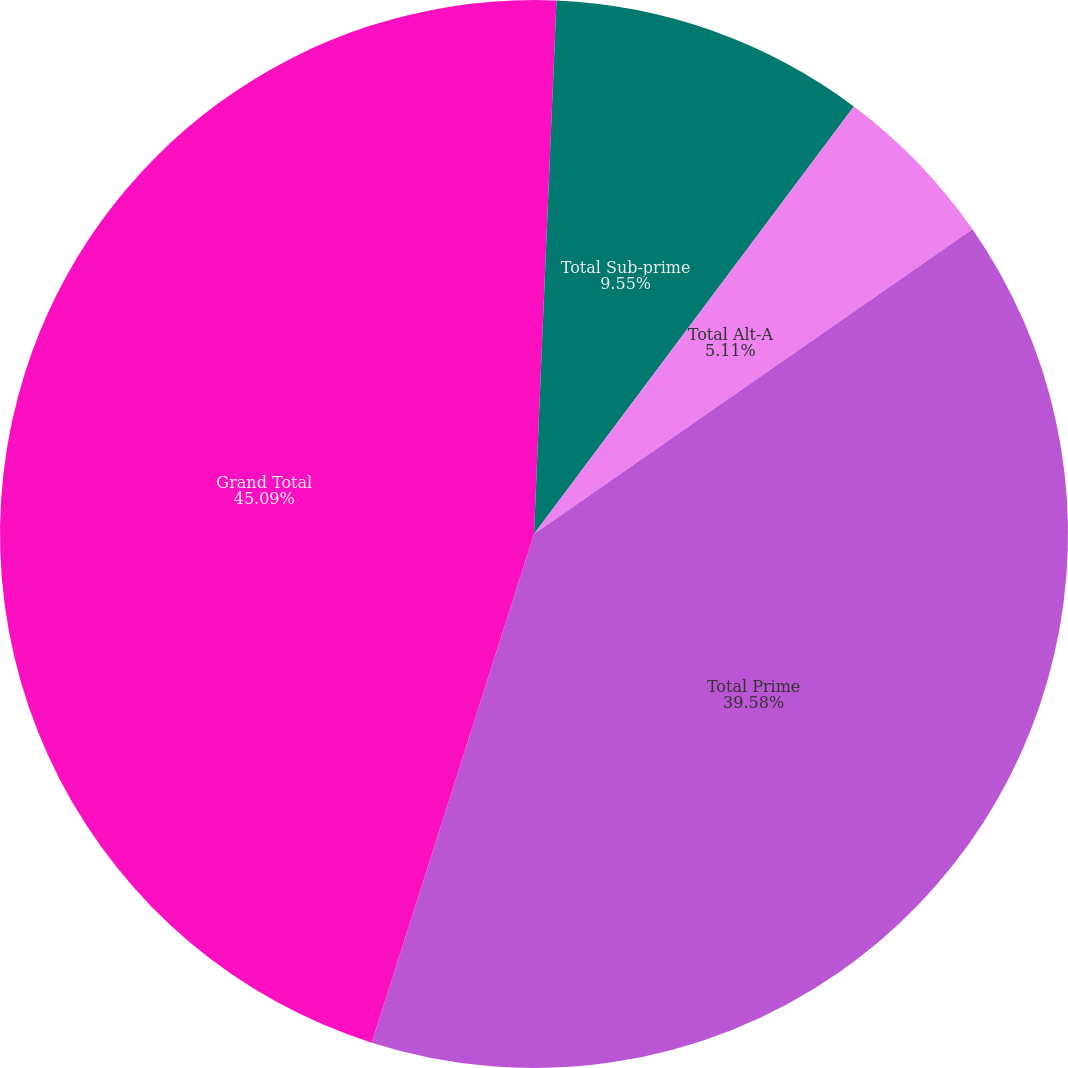Convert chart to OTSL. <chart><loc_0><loc_0><loc_500><loc_500><pie_chart><fcel>2004<fcel>Total Sub-prime<fcel>Total Alt-A<fcel>Total Prime<fcel>Grand Total<nl><fcel>0.67%<fcel>9.55%<fcel>5.11%<fcel>39.58%<fcel>45.08%<nl></chart> 